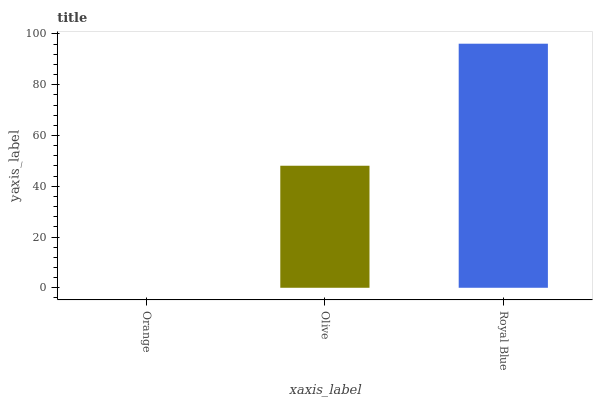Is Olive the minimum?
Answer yes or no. No. Is Olive the maximum?
Answer yes or no. No. Is Olive greater than Orange?
Answer yes or no. Yes. Is Orange less than Olive?
Answer yes or no. Yes. Is Orange greater than Olive?
Answer yes or no. No. Is Olive less than Orange?
Answer yes or no. No. Is Olive the high median?
Answer yes or no. Yes. Is Olive the low median?
Answer yes or no. Yes. Is Orange the high median?
Answer yes or no. No. Is Royal Blue the low median?
Answer yes or no. No. 